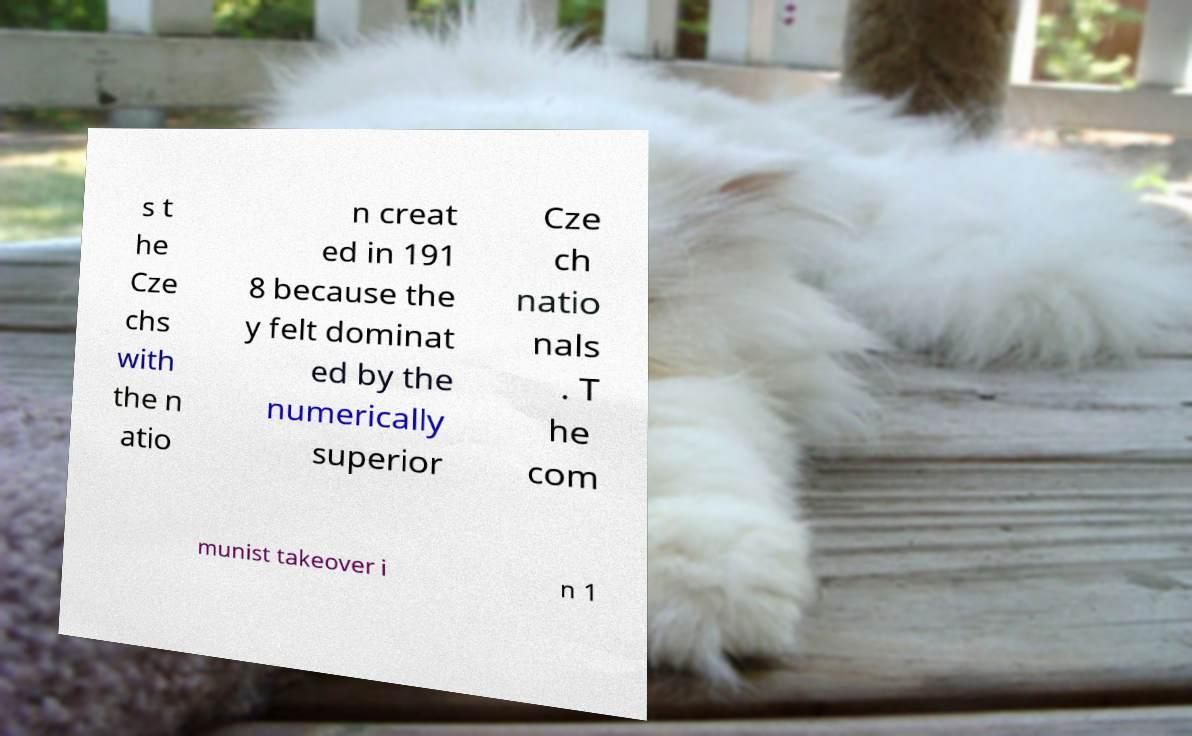What messages or text are displayed in this image? I need them in a readable, typed format. s t he Cze chs with the n atio n creat ed in 191 8 because the y felt dominat ed by the numerically superior Cze ch natio nals . T he com munist takeover i n 1 